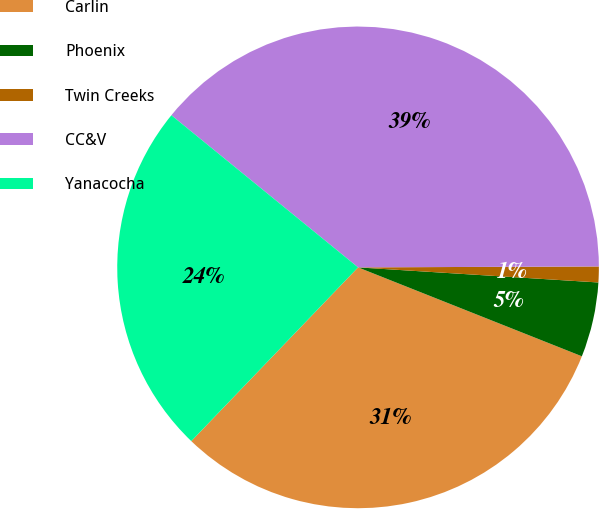Convert chart to OTSL. <chart><loc_0><loc_0><loc_500><loc_500><pie_chart><fcel>Carlin<fcel>Phoenix<fcel>Twin Creeks<fcel>CC&V<fcel>Yanacocha<nl><fcel>31.16%<fcel>5.02%<fcel>1.06%<fcel>39.06%<fcel>23.71%<nl></chart> 